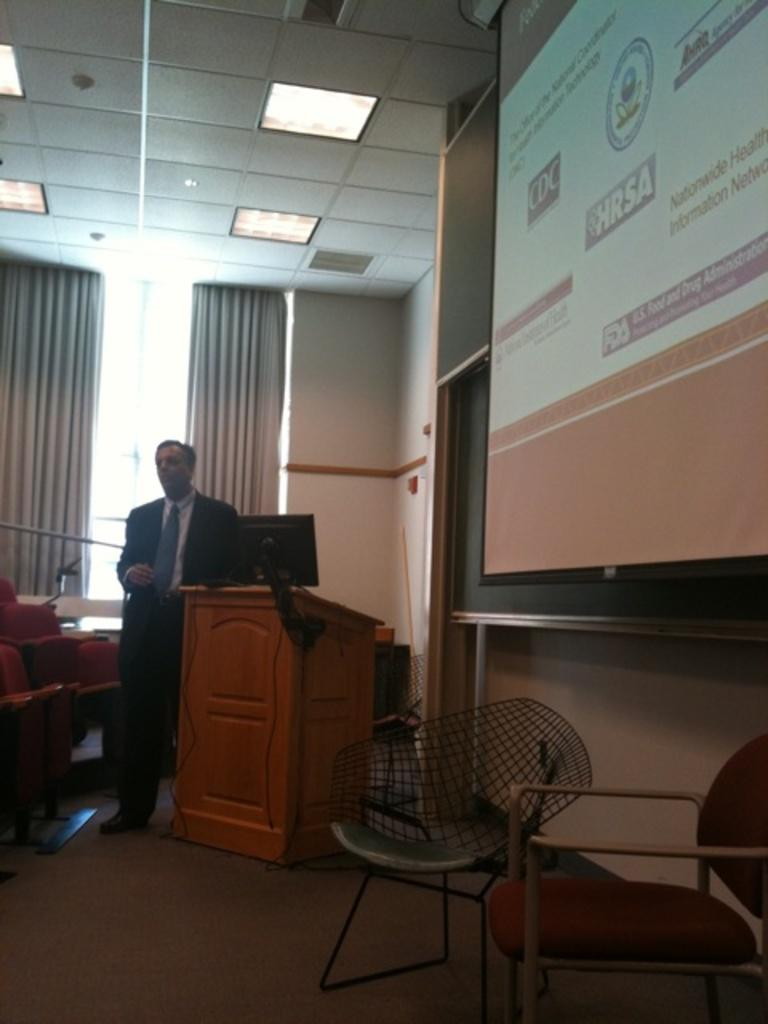How many chairs are in the image? There are two chairs in the image. What is the person in the image wearing? The person in the image is wearing a suit. What can be seen at the right side of the image? There is a screen at the right side of the image. What is visible at the top of the image? There is a roof visible at the top of the image. What type of lead is being used to connect the earth and the net in the image? There is no lead, earth, or net present in the image. 